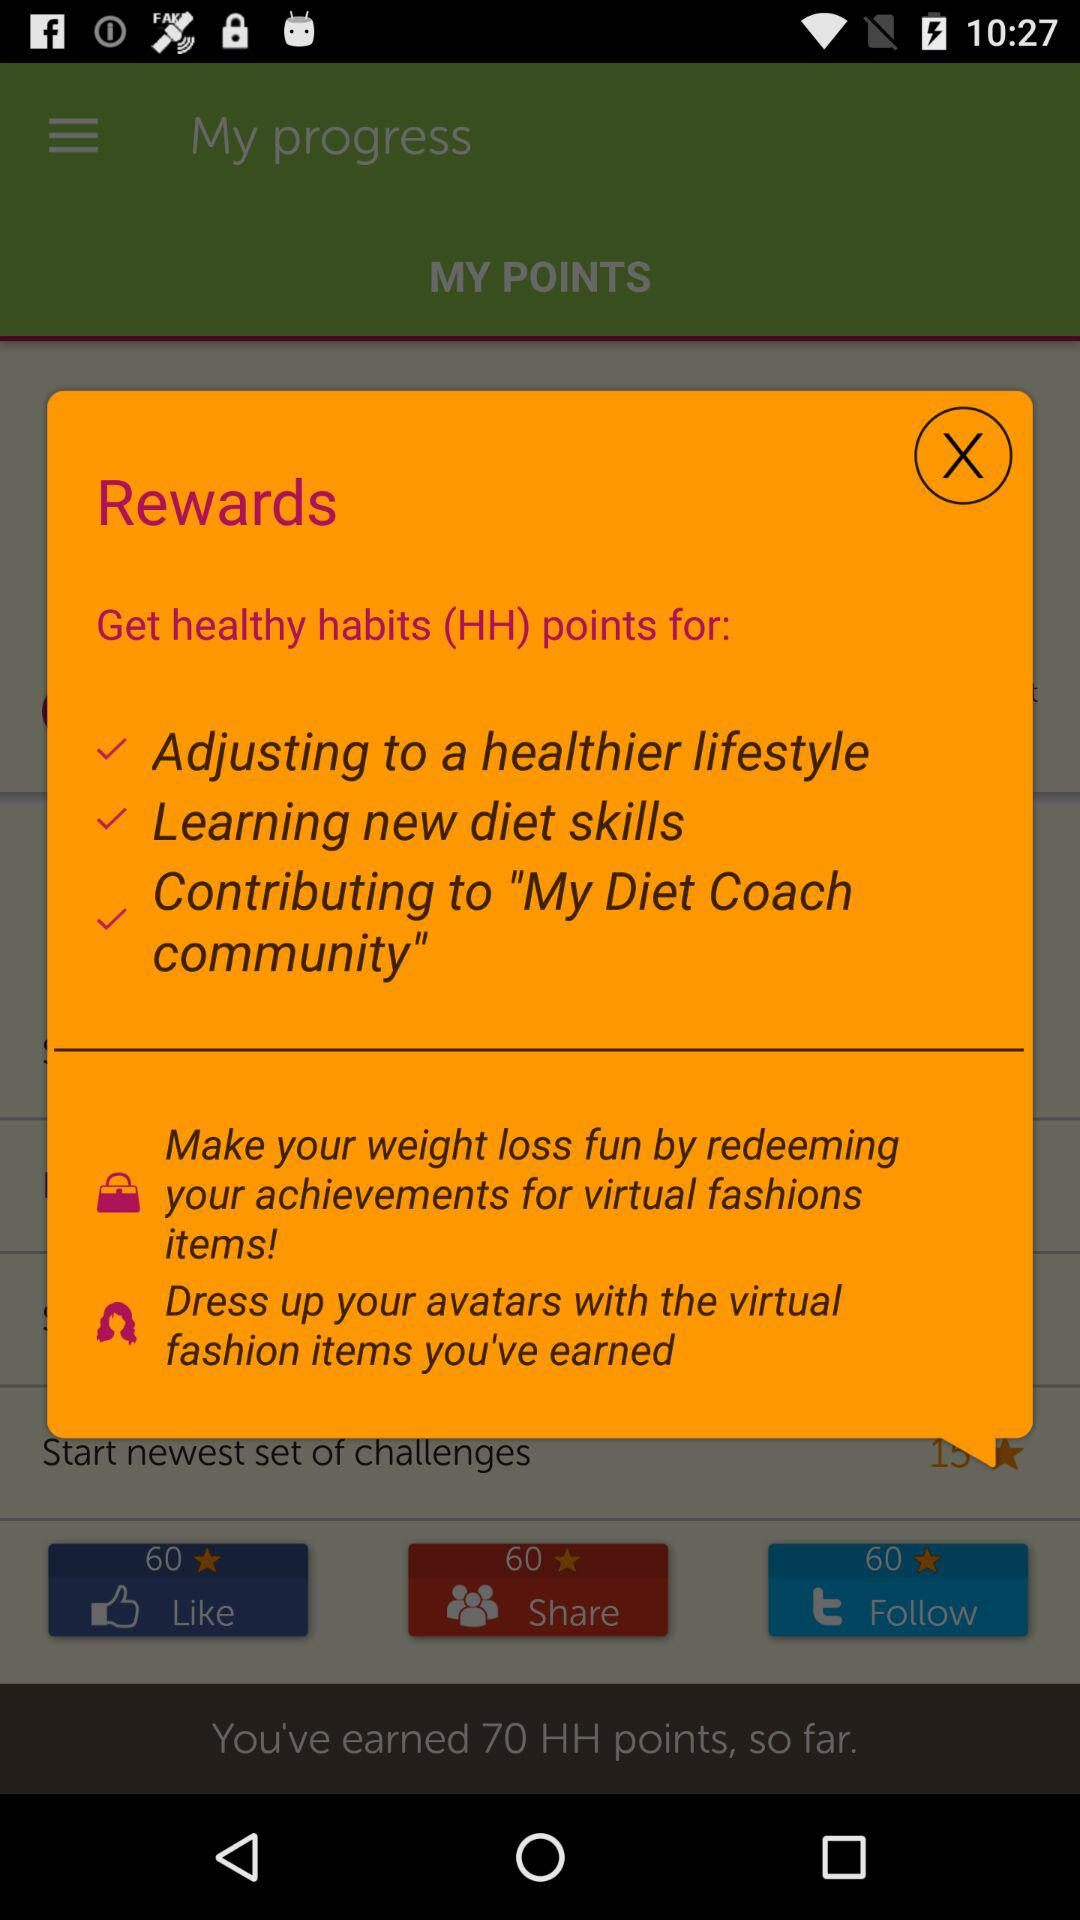How many HH points has the user earned? The user has earned 70 HH points. 